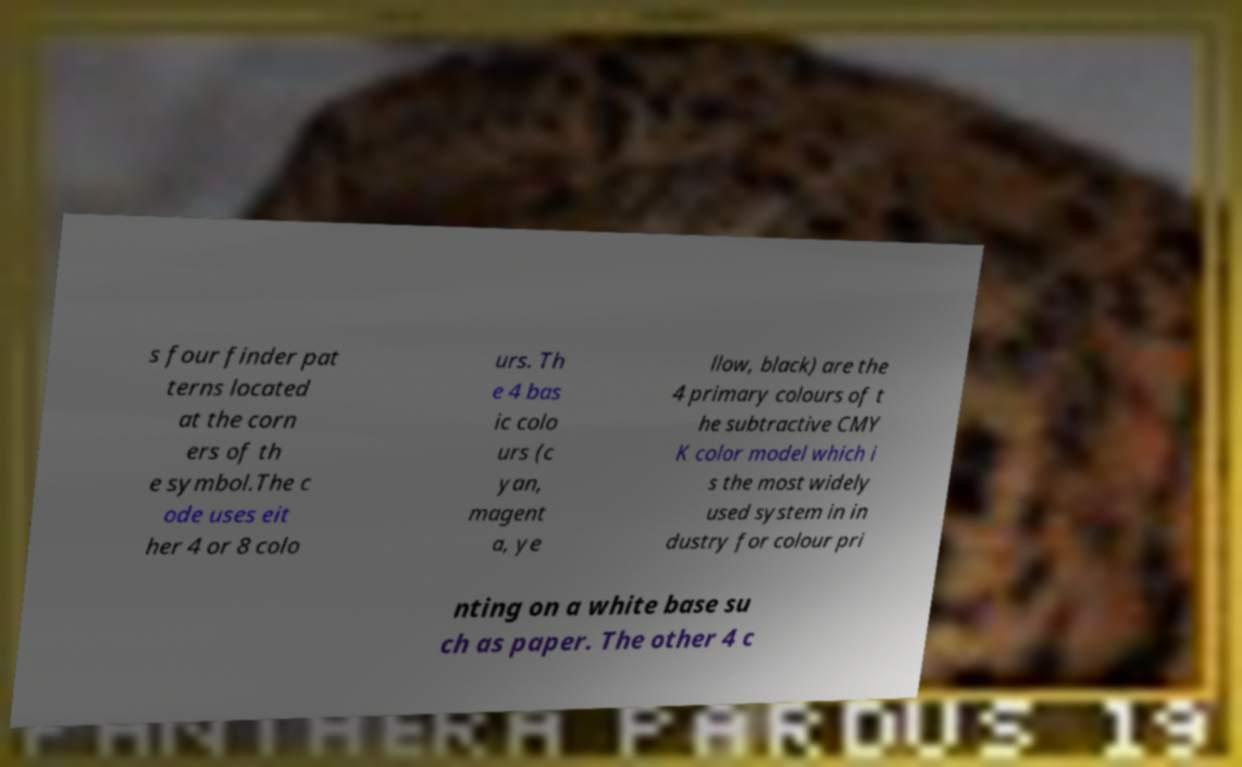What messages or text are displayed in this image? I need them in a readable, typed format. s four finder pat terns located at the corn ers of th e symbol.The c ode uses eit her 4 or 8 colo urs. Th e 4 bas ic colo urs (c yan, magent a, ye llow, black) are the 4 primary colours of t he subtractive CMY K color model which i s the most widely used system in in dustry for colour pri nting on a white base su ch as paper. The other 4 c 